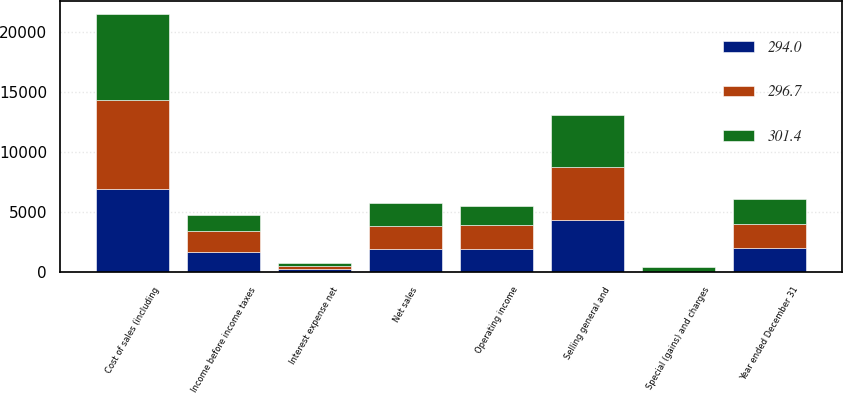Convert chart to OTSL. <chart><loc_0><loc_0><loc_500><loc_500><stacked_bar_chart><ecel><fcel>Year ended December 31<fcel>Net sales<fcel>Cost of sales (including<fcel>Selling general and<fcel>Special (gains) and charges<fcel>Operating income<fcel>Interest expense net<fcel>Income before income taxes<nl><fcel>296.7<fcel>2017<fcel>1915<fcel>7405.1<fcel>4417.1<fcel>3.7<fcel>2019.8<fcel>255<fcel>1764.8<nl><fcel>294<fcel>2016<fcel>1915<fcel>6898.9<fcel>4299.4<fcel>39.5<fcel>1915<fcel>264.6<fcel>1650.4<nl><fcel>301.4<fcel>2015<fcel>1915<fcel>7223.5<fcel>4345.5<fcel>414.8<fcel>1561.3<fcel>243.6<fcel>1317.7<nl></chart> 